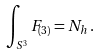Convert formula to latex. <formula><loc_0><loc_0><loc_500><loc_500>\int _ { S ^ { 3 } } F _ { ( 3 ) } = N _ { h } \, .</formula> 